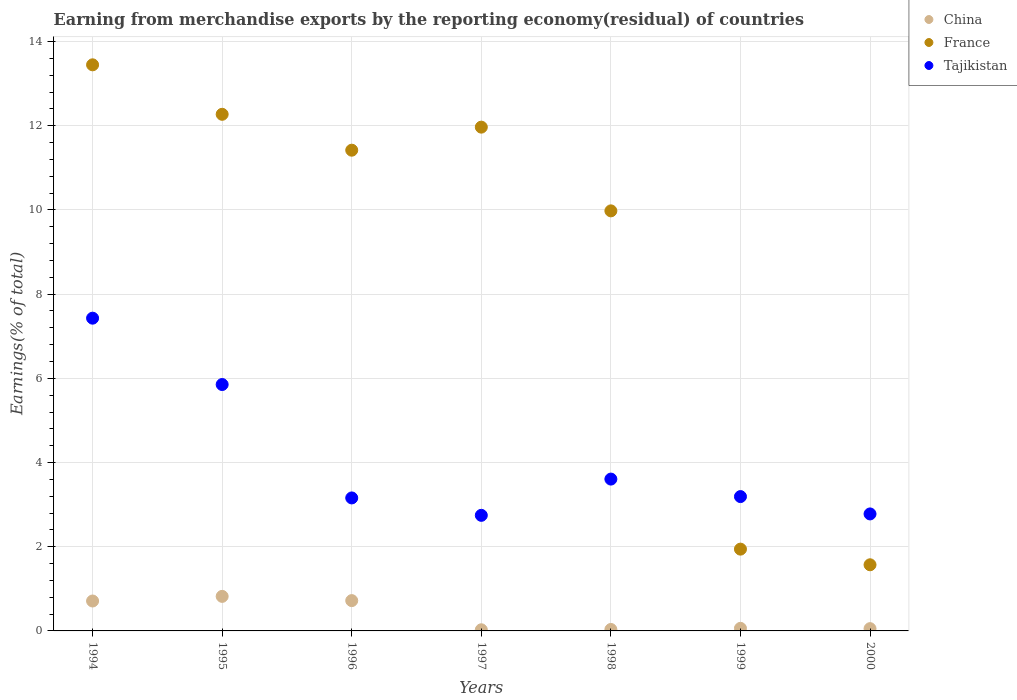How many different coloured dotlines are there?
Your response must be concise. 3. What is the percentage of amount earned from merchandise exports in China in 2000?
Keep it short and to the point. 0.05. Across all years, what is the maximum percentage of amount earned from merchandise exports in China?
Ensure brevity in your answer.  0.82. Across all years, what is the minimum percentage of amount earned from merchandise exports in Tajikistan?
Your answer should be compact. 2.75. What is the total percentage of amount earned from merchandise exports in France in the graph?
Your response must be concise. 62.6. What is the difference between the percentage of amount earned from merchandise exports in Tajikistan in 1996 and that in 1997?
Keep it short and to the point. 0.41. What is the difference between the percentage of amount earned from merchandise exports in France in 1998 and the percentage of amount earned from merchandise exports in China in 1994?
Offer a very short reply. 9.27. What is the average percentage of amount earned from merchandise exports in China per year?
Offer a very short reply. 0.35. In the year 2000, what is the difference between the percentage of amount earned from merchandise exports in France and percentage of amount earned from merchandise exports in Tajikistan?
Your response must be concise. -1.21. In how many years, is the percentage of amount earned from merchandise exports in China greater than 2 %?
Your response must be concise. 0. What is the ratio of the percentage of amount earned from merchandise exports in France in 1997 to that in 2000?
Offer a terse response. 7.62. Is the difference between the percentage of amount earned from merchandise exports in France in 1996 and 1997 greater than the difference between the percentage of amount earned from merchandise exports in Tajikistan in 1996 and 1997?
Keep it short and to the point. No. What is the difference between the highest and the second highest percentage of amount earned from merchandise exports in France?
Give a very brief answer. 1.18. What is the difference between the highest and the lowest percentage of amount earned from merchandise exports in France?
Ensure brevity in your answer.  11.88. In how many years, is the percentage of amount earned from merchandise exports in China greater than the average percentage of amount earned from merchandise exports in China taken over all years?
Keep it short and to the point. 3. Is the sum of the percentage of amount earned from merchandise exports in France in 1994 and 1998 greater than the maximum percentage of amount earned from merchandise exports in China across all years?
Provide a succinct answer. Yes. Is the percentage of amount earned from merchandise exports in China strictly greater than the percentage of amount earned from merchandise exports in Tajikistan over the years?
Give a very brief answer. No. Is the percentage of amount earned from merchandise exports in France strictly less than the percentage of amount earned from merchandise exports in Tajikistan over the years?
Ensure brevity in your answer.  No. Are the values on the major ticks of Y-axis written in scientific E-notation?
Provide a succinct answer. No. Does the graph contain any zero values?
Your answer should be compact. No. Where does the legend appear in the graph?
Your response must be concise. Top right. What is the title of the graph?
Keep it short and to the point. Earning from merchandise exports by the reporting economy(residual) of countries. What is the label or title of the Y-axis?
Give a very brief answer. Earnings(% of total). What is the Earnings(% of total) of China in 1994?
Ensure brevity in your answer.  0.71. What is the Earnings(% of total) of France in 1994?
Provide a short and direct response. 13.45. What is the Earnings(% of total) in Tajikistan in 1994?
Your response must be concise. 7.43. What is the Earnings(% of total) of China in 1995?
Your answer should be very brief. 0.82. What is the Earnings(% of total) in France in 1995?
Provide a short and direct response. 12.27. What is the Earnings(% of total) of Tajikistan in 1995?
Your answer should be very brief. 5.85. What is the Earnings(% of total) in China in 1996?
Offer a very short reply. 0.72. What is the Earnings(% of total) of France in 1996?
Offer a very short reply. 11.42. What is the Earnings(% of total) in Tajikistan in 1996?
Offer a very short reply. 3.16. What is the Earnings(% of total) in China in 1997?
Offer a terse response. 0.03. What is the Earnings(% of total) in France in 1997?
Your answer should be very brief. 11.97. What is the Earnings(% of total) of Tajikistan in 1997?
Make the answer very short. 2.75. What is the Earnings(% of total) of China in 1998?
Offer a very short reply. 0.03. What is the Earnings(% of total) of France in 1998?
Give a very brief answer. 9.98. What is the Earnings(% of total) in Tajikistan in 1998?
Provide a succinct answer. 3.61. What is the Earnings(% of total) of China in 1999?
Provide a short and direct response. 0.06. What is the Earnings(% of total) in France in 1999?
Your answer should be very brief. 1.94. What is the Earnings(% of total) in Tajikistan in 1999?
Provide a short and direct response. 3.19. What is the Earnings(% of total) of China in 2000?
Make the answer very short. 0.05. What is the Earnings(% of total) of France in 2000?
Your answer should be compact. 1.57. What is the Earnings(% of total) in Tajikistan in 2000?
Keep it short and to the point. 2.78. Across all years, what is the maximum Earnings(% of total) in China?
Give a very brief answer. 0.82. Across all years, what is the maximum Earnings(% of total) of France?
Your response must be concise. 13.45. Across all years, what is the maximum Earnings(% of total) of Tajikistan?
Offer a very short reply. 7.43. Across all years, what is the minimum Earnings(% of total) of China?
Your answer should be compact. 0.03. Across all years, what is the minimum Earnings(% of total) in France?
Keep it short and to the point. 1.57. Across all years, what is the minimum Earnings(% of total) of Tajikistan?
Offer a terse response. 2.75. What is the total Earnings(% of total) in China in the graph?
Provide a succinct answer. 2.43. What is the total Earnings(% of total) of France in the graph?
Ensure brevity in your answer.  62.6. What is the total Earnings(% of total) of Tajikistan in the graph?
Make the answer very short. 28.76. What is the difference between the Earnings(% of total) of China in 1994 and that in 1995?
Your answer should be compact. -0.11. What is the difference between the Earnings(% of total) of France in 1994 and that in 1995?
Provide a short and direct response. 1.18. What is the difference between the Earnings(% of total) in Tajikistan in 1994 and that in 1995?
Your answer should be compact. 1.58. What is the difference between the Earnings(% of total) of China in 1994 and that in 1996?
Ensure brevity in your answer.  -0.01. What is the difference between the Earnings(% of total) in France in 1994 and that in 1996?
Your answer should be compact. 2.03. What is the difference between the Earnings(% of total) of Tajikistan in 1994 and that in 1996?
Provide a short and direct response. 4.27. What is the difference between the Earnings(% of total) in China in 1994 and that in 1997?
Your response must be concise. 0.68. What is the difference between the Earnings(% of total) in France in 1994 and that in 1997?
Your response must be concise. 1.48. What is the difference between the Earnings(% of total) in Tajikistan in 1994 and that in 1997?
Make the answer very short. 4.68. What is the difference between the Earnings(% of total) in China in 1994 and that in 1998?
Ensure brevity in your answer.  0.68. What is the difference between the Earnings(% of total) of France in 1994 and that in 1998?
Your answer should be compact. 3.47. What is the difference between the Earnings(% of total) of Tajikistan in 1994 and that in 1998?
Your answer should be compact. 3.82. What is the difference between the Earnings(% of total) of China in 1994 and that in 1999?
Provide a short and direct response. 0.65. What is the difference between the Earnings(% of total) in France in 1994 and that in 1999?
Your response must be concise. 11.5. What is the difference between the Earnings(% of total) in Tajikistan in 1994 and that in 1999?
Your response must be concise. 4.24. What is the difference between the Earnings(% of total) of China in 1994 and that in 2000?
Provide a succinct answer. 0.66. What is the difference between the Earnings(% of total) in France in 1994 and that in 2000?
Offer a very short reply. 11.88. What is the difference between the Earnings(% of total) of Tajikistan in 1994 and that in 2000?
Your answer should be compact. 4.65. What is the difference between the Earnings(% of total) in China in 1995 and that in 1996?
Your response must be concise. 0.1. What is the difference between the Earnings(% of total) in France in 1995 and that in 1996?
Offer a very short reply. 0.85. What is the difference between the Earnings(% of total) in Tajikistan in 1995 and that in 1996?
Provide a succinct answer. 2.69. What is the difference between the Earnings(% of total) in China in 1995 and that in 1997?
Provide a succinct answer. 0.79. What is the difference between the Earnings(% of total) in France in 1995 and that in 1997?
Provide a short and direct response. 0.3. What is the difference between the Earnings(% of total) of Tajikistan in 1995 and that in 1997?
Give a very brief answer. 3.11. What is the difference between the Earnings(% of total) in China in 1995 and that in 1998?
Offer a terse response. 0.79. What is the difference between the Earnings(% of total) in France in 1995 and that in 1998?
Your answer should be compact. 2.29. What is the difference between the Earnings(% of total) in Tajikistan in 1995 and that in 1998?
Your answer should be very brief. 2.25. What is the difference between the Earnings(% of total) of China in 1995 and that in 1999?
Your answer should be very brief. 0.76. What is the difference between the Earnings(% of total) in France in 1995 and that in 1999?
Make the answer very short. 10.33. What is the difference between the Earnings(% of total) in Tajikistan in 1995 and that in 1999?
Offer a terse response. 2.66. What is the difference between the Earnings(% of total) in China in 1995 and that in 2000?
Make the answer very short. 0.77. What is the difference between the Earnings(% of total) in France in 1995 and that in 2000?
Offer a very short reply. 10.7. What is the difference between the Earnings(% of total) in Tajikistan in 1995 and that in 2000?
Offer a very short reply. 3.07. What is the difference between the Earnings(% of total) in China in 1996 and that in 1997?
Offer a very short reply. 0.69. What is the difference between the Earnings(% of total) of France in 1996 and that in 1997?
Provide a short and direct response. -0.55. What is the difference between the Earnings(% of total) of Tajikistan in 1996 and that in 1997?
Keep it short and to the point. 0.41. What is the difference between the Earnings(% of total) of China in 1996 and that in 1998?
Make the answer very short. 0.69. What is the difference between the Earnings(% of total) in France in 1996 and that in 1998?
Provide a short and direct response. 1.44. What is the difference between the Earnings(% of total) of Tajikistan in 1996 and that in 1998?
Give a very brief answer. -0.45. What is the difference between the Earnings(% of total) of China in 1996 and that in 1999?
Keep it short and to the point. 0.66. What is the difference between the Earnings(% of total) in France in 1996 and that in 1999?
Give a very brief answer. 9.48. What is the difference between the Earnings(% of total) in Tajikistan in 1996 and that in 1999?
Make the answer very short. -0.03. What is the difference between the Earnings(% of total) of China in 1996 and that in 2000?
Your response must be concise. 0.67. What is the difference between the Earnings(% of total) of France in 1996 and that in 2000?
Ensure brevity in your answer.  9.85. What is the difference between the Earnings(% of total) in Tajikistan in 1996 and that in 2000?
Your answer should be very brief. 0.38. What is the difference between the Earnings(% of total) of China in 1997 and that in 1998?
Your answer should be compact. -0.01. What is the difference between the Earnings(% of total) of France in 1997 and that in 1998?
Make the answer very short. 1.99. What is the difference between the Earnings(% of total) of Tajikistan in 1997 and that in 1998?
Your response must be concise. -0.86. What is the difference between the Earnings(% of total) of China in 1997 and that in 1999?
Make the answer very short. -0.03. What is the difference between the Earnings(% of total) in France in 1997 and that in 1999?
Your answer should be compact. 10.02. What is the difference between the Earnings(% of total) of Tajikistan in 1997 and that in 1999?
Make the answer very short. -0.45. What is the difference between the Earnings(% of total) in China in 1997 and that in 2000?
Make the answer very short. -0.03. What is the difference between the Earnings(% of total) in France in 1997 and that in 2000?
Make the answer very short. 10.4. What is the difference between the Earnings(% of total) in Tajikistan in 1997 and that in 2000?
Keep it short and to the point. -0.03. What is the difference between the Earnings(% of total) of China in 1998 and that in 1999?
Provide a succinct answer. -0.03. What is the difference between the Earnings(% of total) of France in 1998 and that in 1999?
Your answer should be compact. 8.04. What is the difference between the Earnings(% of total) in Tajikistan in 1998 and that in 1999?
Offer a very short reply. 0.42. What is the difference between the Earnings(% of total) in China in 1998 and that in 2000?
Keep it short and to the point. -0.02. What is the difference between the Earnings(% of total) of France in 1998 and that in 2000?
Ensure brevity in your answer.  8.41. What is the difference between the Earnings(% of total) of Tajikistan in 1998 and that in 2000?
Offer a terse response. 0.83. What is the difference between the Earnings(% of total) in China in 1999 and that in 2000?
Offer a terse response. 0.01. What is the difference between the Earnings(% of total) in France in 1999 and that in 2000?
Keep it short and to the point. 0.37. What is the difference between the Earnings(% of total) of Tajikistan in 1999 and that in 2000?
Give a very brief answer. 0.41. What is the difference between the Earnings(% of total) of China in 1994 and the Earnings(% of total) of France in 1995?
Your answer should be very brief. -11.56. What is the difference between the Earnings(% of total) in China in 1994 and the Earnings(% of total) in Tajikistan in 1995?
Keep it short and to the point. -5.14. What is the difference between the Earnings(% of total) in France in 1994 and the Earnings(% of total) in Tajikistan in 1995?
Provide a succinct answer. 7.59. What is the difference between the Earnings(% of total) of China in 1994 and the Earnings(% of total) of France in 1996?
Offer a terse response. -10.71. What is the difference between the Earnings(% of total) of China in 1994 and the Earnings(% of total) of Tajikistan in 1996?
Offer a terse response. -2.45. What is the difference between the Earnings(% of total) in France in 1994 and the Earnings(% of total) in Tajikistan in 1996?
Give a very brief answer. 10.29. What is the difference between the Earnings(% of total) of China in 1994 and the Earnings(% of total) of France in 1997?
Make the answer very short. -11.26. What is the difference between the Earnings(% of total) of China in 1994 and the Earnings(% of total) of Tajikistan in 1997?
Offer a terse response. -2.04. What is the difference between the Earnings(% of total) in France in 1994 and the Earnings(% of total) in Tajikistan in 1997?
Your answer should be very brief. 10.7. What is the difference between the Earnings(% of total) in China in 1994 and the Earnings(% of total) in France in 1998?
Provide a succinct answer. -9.27. What is the difference between the Earnings(% of total) of China in 1994 and the Earnings(% of total) of Tajikistan in 1998?
Keep it short and to the point. -2.9. What is the difference between the Earnings(% of total) of France in 1994 and the Earnings(% of total) of Tajikistan in 1998?
Offer a very short reply. 9.84. What is the difference between the Earnings(% of total) of China in 1994 and the Earnings(% of total) of France in 1999?
Offer a terse response. -1.23. What is the difference between the Earnings(% of total) in China in 1994 and the Earnings(% of total) in Tajikistan in 1999?
Offer a very short reply. -2.48. What is the difference between the Earnings(% of total) of France in 1994 and the Earnings(% of total) of Tajikistan in 1999?
Make the answer very short. 10.26. What is the difference between the Earnings(% of total) in China in 1994 and the Earnings(% of total) in France in 2000?
Offer a very short reply. -0.86. What is the difference between the Earnings(% of total) in China in 1994 and the Earnings(% of total) in Tajikistan in 2000?
Keep it short and to the point. -2.07. What is the difference between the Earnings(% of total) in France in 1994 and the Earnings(% of total) in Tajikistan in 2000?
Offer a very short reply. 10.67. What is the difference between the Earnings(% of total) of China in 1995 and the Earnings(% of total) of France in 1996?
Offer a terse response. -10.6. What is the difference between the Earnings(% of total) of China in 1995 and the Earnings(% of total) of Tajikistan in 1996?
Your answer should be compact. -2.34. What is the difference between the Earnings(% of total) of France in 1995 and the Earnings(% of total) of Tajikistan in 1996?
Provide a short and direct response. 9.11. What is the difference between the Earnings(% of total) of China in 1995 and the Earnings(% of total) of France in 1997?
Provide a succinct answer. -11.15. What is the difference between the Earnings(% of total) of China in 1995 and the Earnings(% of total) of Tajikistan in 1997?
Your response must be concise. -1.93. What is the difference between the Earnings(% of total) in France in 1995 and the Earnings(% of total) in Tajikistan in 1997?
Make the answer very short. 9.53. What is the difference between the Earnings(% of total) of China in 1995 and the Earnings(% of total) of France in 1998?
Your response must be concise. -9.16. What is the difference between the Earnings(% of total) of China in 1995 and the Earnings(% of total) of Tajikistan in 1998?
Provide a short and direct response. -2.79. What is the difference between the Earnings(% of total) in France in 1995 and the Earnings(% of total) in Tajikistan in 1998?
Provide a succinct answer. 8.67. What is the difference between the Earnings(% of total) in China in 1995 and the Earnings(% of total) in France in 1999?
Your answer should be compact. -1.12. What is the difference between the Earnings(% of total) of China in 1995 and the Earnings(% of total) of Tajikistan in 1999?
Your response must be concise. -2.37. What is the difference between the Earnings(% of total) of France in 1995 and the Earnings(% of total) of Tajikistan in 1999?
Ensure brevity in your answer.  9.08. What is the difference between the Earnings(% of total) of China in 1995 and the Earnings(% of total) of France in 2000?
Give a very brief answer. -0.75. What is the difference between the Earnings(% of total) of China in 1995 and the Earnings(% of total) of Tajikistan in 2000?
Offer a terse response. -1.96. What is the difference between the Earnings(% of total) in France in 1995 and the Earnings(% of total) in Tajikistan in 2000?
Your response must be concise. 9.49. What is the difference between the Earnings(% of total) in China in 1996 and the Earnings(% of total) in France in 1997?
Your answer should be compact. -11.25. What is the difference between the Earnings(% of total) of China in 1996 and the Earnings(% of total) of Tajikistan in 1997?
Provide a succinct answer. -2.03. What is the difference between the Earnings(% of total) in France in 1996 and the Earnings(% of total) in Tajikistan in 1997?
Offer a terse response. 8.67. What is the difference between the Earnings(% of total) in China in 1996 and the Earnings(% of total) in France in 1998?
Offer a terse response. -9.26. What is the difference between the Earnings(% of total) of China in 1996 and the Earnings(% of total) of Tajikistan in 1998?
Your response must be concise. -2.89. What is the difference between the Earnings(% of total) in France in 1996 and the Earnings(% of total) in Tajikistan in 1998?
Your answer should be compact. 7.81. What is the difference between the Earnings(% of total) in China in 1996 and the Earnings(% of total) in France in 1999?
Ensure brevity in your answer.  -1.22. What is the difference between the Earnings(% of total) in China in 1996 and the Earnings(% of total) in Tajikistan in 1999?
Provide a succinct answer. -2.47. What is the difference between the Earnings(% of total) in France in 1996 and the Earnings(% of total) in Tajikistan in 1999?
Provide a short and direct response. 8.23. What is the difference between the Earnings(% of total) in China in 1996 and the Earnings(% of total) in France in 2000?
Ensure brevity in your answer.  -0.85. What is the difference between the Earnings(% of total) of China in 1996 and the Earnings(% of total) of Tajikistan in 2000?
Offer a very short reply. -2.06. What is the difference between the Earnings(% of total) of France in 1996 and the Earnings(% of total) of Tajikistan in 2000?
Your answer should be very brief. 8.64. What is the difference between the Earnings(% of total) in China in 1997 and the Earnings(% of total) in France in 1998?
Keep it short and to the point. -9.95. What is the difference between the Earnings(% of total) of China in 1997 and the Earnings(% of total) of Tajikistan in 1998?
Your answer should be very brief. -3.58. What is the difference between the Earnings(% of total) in France in 1997 and the Earnings(% of total) in Tajikistan in 1998?
Make the answer very short. 8.36. What is the difference between the Earnings(% of total) of China in 1997 and the Earnings(% of total) of France in 1999?
Your response must be concise. -1.92. What is the difference between the Earnings(% of total) of China in 1997 and the Earnings(% of total) of Tajikistan in 1999?
Make the answer very short. -3.16. What is the difference between the Earnings(% of total) of France in 1997 and the Earnings(% of total) of Tajikistan in 1999?
Provide a succinct answer. 8.78. What is the difference between the Earnings(% of total) of China in 1997 and the Earnings(% of total) of France in 2000?
Ensure brevity in your answer.  -1.54. What is the difference between the Earnings(% of total) in China in 1997 and the Earnings(% of total) in Tajikistan in 2000?
Provide a short and direct response. -2.75. What is the difference between the Earnings(% of total) in France in 1997 and the Earnings(% of total) in Tajikistan in 2000?
Your answer should be compact. 9.19. What is the difference between the Earnings(% of total) in China in 1998 and the Earnings(% of total) in France in 1999?
Offer a very short reply. -1.91. What is the difference between the Earnings(% of total) of China in 1998 and the Earnings(% of total) of Tajikistan in 1999?
Your response must be concise. -3.16. What is the difference between the Earnings(% of total) of France in 1998 and the Earnings(% of total) of Tajikistan in 1999?
Your answer should be very brief. 6.79. What is the difference between the Earnings(% of total) of China in 1998 and the Earnings(% of total) of France in 2000?
Give a very brief answer. -1.54. What is the difference between the Earnings(% of total) in China in 1998 and the Earnings(% of total) in Tajikistan in 2000?
Keep it short and to the point. -2.74. What is the difference between the Earnings(% of total) in France in 1998 and the Earnings(% of total) in Tajikistan in 2000?
Ensure brevity in your answer.  7.2. What is the difference between the Earnings(% of total) in China in 1999 and the Earnings(% of total) in France in 2000?
Keep it short and to the point. -1.51. What is the difference between the Earnings(% of total) in China in 1999 and the Earnings(% of total) in Tajikistan in 2000?
Ensure brevity in your answer.  -2.72. What is the difference between the Earnings(% of total) of France in 1999 and the Earnings(% of total) of Tajikistan in 2000?
Your answer should be compact. -0.84. What is the average Earnings(% of total) of China per year?
Offer a terse response. 0.35. What is the average Earnings(% of total) in France per year?
Give a very brief answer. 8.94. What is the average Earnings(% of total) of Tajikistan per year?
Offer a very short reply. 4.11. In the year 1994, what is the difference between the Earnings(% of total) of China and Earnings(% of total) of France?
Offer a terse response. -12.74. In the year 1994, what is the difference between the Earnings(% of total) of China and Earnings(% of total) of Tajikistan?
Ensure brevity in your answer.  -6.72. In the year 1994, what is the difference between the Earnings(% of total) of France and Earnings(% of total) of Tajikistan?
Provide a short and direct response. 6.02. In the year 1995, what is the difference between the Earnings(% of total) in China and Earnings(% of total) in France?
Provide a short and direct response. -11.45. In the year 1995, what is the difference between the Earnings(% of total) in China and Earnings(% of total) in Tajikistan?
Give a very brief answer. -5.03. In the year 1995, what is the difference between the Earnings(% of total) in France and Earnings(% of total) in Tajikistan?
Provide a short and direct response. 6.42. In the year 1996, what is the difference between the Earnings(% of total) of China and Earnings(% of total) of France?
Your answer should be very brief. -10.7. In the year 1996, what is the difference between the Earnings(% of total) of China and Earnings(% of total) of Tajikistan?
Your response must be concise. -2.44. In the year 1996, what is the difference between the Earnings(% of total) of France and Earnings(% of total) of Tajikistan?
Your answer should be very brief. 8.26. In the year 1997, what is the difference between the Earnings(% of total) in China and Earnings(% of total) in France?
Your response must be concise. -11.94. In the year 1997, what is the difference between the Earnings(% of total) of China and Earnings(% of total) of Tajikistan?
Your response must be concise. -2.72. In the year 1997, what is the difference between the Earnings(% of total) of France and Earnings(% of total) of Tajikistan?
Make the answer very short. 9.22. In the year 1998, what is the difference between the Earnings(% of total) of China and Earnings(% of total) of France?
Offer a very short reply. -9.94. In the year 1998, what is the difference between the Earnings(% of total) of China and Earnings(% of total) of Tajikistan?
Provide a succinct answer. -3.57. In the year 1998, what is the difference between the Earnings(% of total) in France and Earnings(% of total) in Tajikistan?
Provide a short and direct response. 6.37. In the year 1999, what is the difference between the Earnings(% of total) of China and Earnings(% of total) of France?
Ensure brevity in your answer.  -1.88. In the year 1999, what is the difference between the Earnings(% of total) in China and Earnings(% of total) in Tajikistan?
Your answer should be compact. -3.13. In the year 1999, what is the difference between the Earnings(% of total) in France and Earnings(% of total) in Tajikistan?
Your answer should be compact. -1.25. In the year 2000, what is the difference between the Earnings(% of total) of China and Earnings(% of total) of France?
Provide a short and direct response. -1.52. In the year 2000, what is the difference between the Earnings(% of total) of China and Earnings(% of total) of Tajikistan?
Offer a terse response. -2.73. In the year 2000, what is the difference between the Earnings(% of total) of France and Earnings(% of total) of Tajikistan?
Your answer should be compact. -1.21. What is the ratio of the Earnings(% of total) in China in 1994 to that in 1995?
Your answer should be compact. 0.87. What is the ratio of the Earnings(% of total) in France in 1994 to that in 1995?
Provide a short and direct response. 1.1. What is the ratio of the Earnings(% of total) of Tajikistan in 1994 to that in 1995?
Your response must be concise. 1.27. What is the ratio of the Earnings(% of total) of China in 1994 to that in 1996?
Ensure brevity in your answer.  0.99. What is the ratio of the Earnings(% of total) of France in 1994 to that in 1996?
Give a very brief answer. 1.18. What is the ratio of the Earnings(% of total) of Tajikistan in 1994 to that in 1996?
Keep it short and to the point. 2.35. What is the ratio of the Earnings(% of total) of China in 1994 to that in 1997?
Provide a short and direct response. 26.22. What is the ratio of the Earnings(% of total) of France in 1994 to that in 1997?
Offer a terse response. 1.12. What is the ratio of the Earnings(% of total) of Tajikistan in 1994 to that in 1997?
Your answer should be compact. 2.71. What is the ratio of the Earnings(% of total) in China in 1994 to that in 1998?
Offer a terse response. 20.66. What is the ratio of the Earnings(% of total) in France in 1994 to that in 1998?
Make the answer very short. 1.35. What is the ratio of the Earnings(% of total) of Tajikistan in 1994 to that in 1998?
Offer a terse response. 2.06. What is the ratio of the Earnings(% of total) of China in 1994 to that in 1999?
Your response must be concise. 11.62. What is the ratio of the Earnings(% of total) of France in 1994 to that in 1999?
Provide a short and direct response. 6.92. What is the ratio of the Earnings(% of total) in Tajikistan in 1994 to that in 1999?
Offer a very short reply. 2.33. What is the ratio of the Earnings(% of total) of China in 1994 to that in 2000?
Make the answer very short. 13.12. What is the ratio of the Earnings(% of total) in France in 1994 to that in 2000?
Your answer should be very brief. 8.56. What is the ratio of the Earnings(% of total) in Tajikistan in 1994 to that in 2000?
Give a very brief answer. 2.67. What is the ratio of the Earnings(% of total) of China in 1995 to that in 1996?
Offer a very short reply. 1.14. What is the ratio of the Earnings(% of total) in France in 1995 to that in 1996?
Make the answer very short. 1.07. What is the ratio of the Earnings(% of total) of Tajikistan in 1995 to that in 1996?
Your answer should be very brief. 1.85. What is the ratio of the Earnings(% of total) of China in 1995 to that in 1997?
Offer a very short reply. 30.27. What is the ratio of the Earnings(% of total) in France in 1995 to that in 1997?
Give a very brief answer. 1.03. What is the ratio of the Earnings(% of total) in Tajikistan in 1995 to that in 1997?
Provide a short and direct response. 2.13. What is the ratio of the Earnings(% of total) of China in 1995 to that in 1998?
Offer a terse response. 23.86. What is the ratio of the Earnings(% of total) of France in 1995 to that in 1998?
Offer a terse response. 1.23. What is the ratio of the Earnings(% of total) in Tajikistan in 1995 to that in 1998?
Keep it short and to the point. 1.62. What is the ratio of the Earnings(% of total) in China in 1995 to that in 1999?
Provide a succinct answer. 13.42. What is the ratio of the Earnings(% of total) of France in 1995 to that in 1999?
Offer a very short reply. 6.32. What is the ratio of the Earnings(% of total) of Tajikistan in 1995 to that in 1999?
Provide a short and direct response. 1.83. What is the ratio of the Earnings(% of total) of China in 1995 to that in 2000?
Offer a very short reply. 15.15. What is the ratio of the Earnings(% of total) of France in 1995 to that in 2000?
Offer a terse response. 7.81. What is the ratio of the Earnings(% of total) in Tajikistan in 1995 to that in 2000?
Offer a terse response. 2.11. What is the ratio of the Earnings(% of total) of China in 1996 to that in 1997?
Offer a terse response. 26.56. What is the ratio of the Earnings(% of total) of France in 1996 to that in 1997?
Provide a succinct answer. 0.95. What is the ratio of the Earnings(% of total) in Tajikistan in 1996 to that in 1997?
Make the answer very short. 1.15. What is the ratio of the Earnings(% of total) of China in 1996 to that in 1998?
Keep it short and to the point. 20.93. What is the ratio of the Earnings(% of total) of France in 1996 to that in 1998?
Your answer should be very brief. 1.14. What is the ratio of the Earnings(% of total) in Tajikistan in 1996 to that in 1998?
Provide a succinct answer. 0.88. What is the ratio of the Earnings(% of total) in China in 1996 to that in 1999?
Keep it short and to the point. 11.77. What is the ratio of the Earnings(% of total) in France in 1996 to that in 1999?
Offer a very short reply. 5.88. What is the ratio of the Earnings(% of total) of Tajikistan in 1996 to that in 1999?
Keep it short and to the point. 0.99. What is the ratio of the Earnings(% of total) of China in 1996 to that in 2000?
Give a very brief answer. 13.29. What is the ratio of the Earnings(% of total) of France in 1996 to that in 2000?
Provide a succinct answer. 7.27. What is the ratio of the Earnings(% of total) in Tajikistan in 1996 to that in 2000?
Your answer should be compact. 1.14. What is the ratio of the Earnings(% of total) in China in 1997 to that in 1998?
Your answer should be very brief. 0.79. What is the ratio of the Earnings(% of total) in France in 1997 to that in 1998?
Make the answer very short. 1.2. What is the ratio of the Earnings(% of total) of Tajikistan in 1997 to that in 1998?
Give a very brief answer. 0.76. What is the ratio of the Earnings(% of total) of China in 1997 to that in 1999?
Your answer should be very brief. 0.44. What is the ratio of the Earnings(% of total) of France in 1997 to that in 1999?
Offer a very short reply. 6.16. What is the ratio of the Earnings(% of total) of Tajikistan in 1997 to that in 1999?
Offer a very short reply. 0.86. What is the ratio of the Earnings(% of total) in China in 1997 to that in 2000?
Offer a very short reply. 0.5. What is the ratio of the Earnings(% of total) of France in 1997 to that in 2000?
Give a very brief answer. 7.62. What is the ratio of the Earnings(% of total) in Tajikistan in 1997 to that in 2000?
Provide a short and direct response. 0.99. What is the ratio of the Earnings(% of total) of China in 1998 to that in 1999?
Your answer should be compact. 0.56. What is the ratio of the Earnings(% of total) in France in 1998 to that in 1999?
Offer a very short reply. 5.14. What is the ratio of the Earnings(% of total) in Tajikistan in 1998 to that in 1999?
Your response must be concise. 1.13. What is the ratio of the Earnings(% of total) in China in 1998 to that in 2000?
Offer a terse response. 0.63. What is the ratio of the Earnings(% of total) in France in 1998 to that in 2000?
Keep it short and to the point. 6.35. What is the ratio of the Earnings(% of total) in Tajikistan in 1998 to that in 2000?
Make the answer very short. 1.3. What is the ratio of the Earnings(% of total) of China in 1999 to that in 2000?
Provide a succinct answer. 1.13. What is the ratio of the Earnings(% of total) in France in 1999 to that in 2000?
Your answer should be very brief. 1.24. What is the ratio of the Earnings(% of total) of Tajikistan in 1999 to that in 2000?
Provide a succinct answer. 1.15. What is the difference between the highest and the second highest Earnings(% of total) of China?
Ensure brevity in your answer.  0.1. What is the difference between the highest and the second highest Earnings(% of total) of France?
Ensure brevity in your answer.  1.18. What is the difference between the highest and the second highest Earnings(% of total) of Tajikistan?
Provide a short and direct response. 1.58. What is the difference between the highest and the lowest Earnings(% of total) of China?
Give a very brief answer. 0.79. What is the difference between the highest and the lowest Earnings(% of total) of France?
Provide a short and direct response. 11.88. What is the difference between the highest and the lowest Earnings(% of total) of Tajikistan?
Provide a short and direct response. 4.68. 